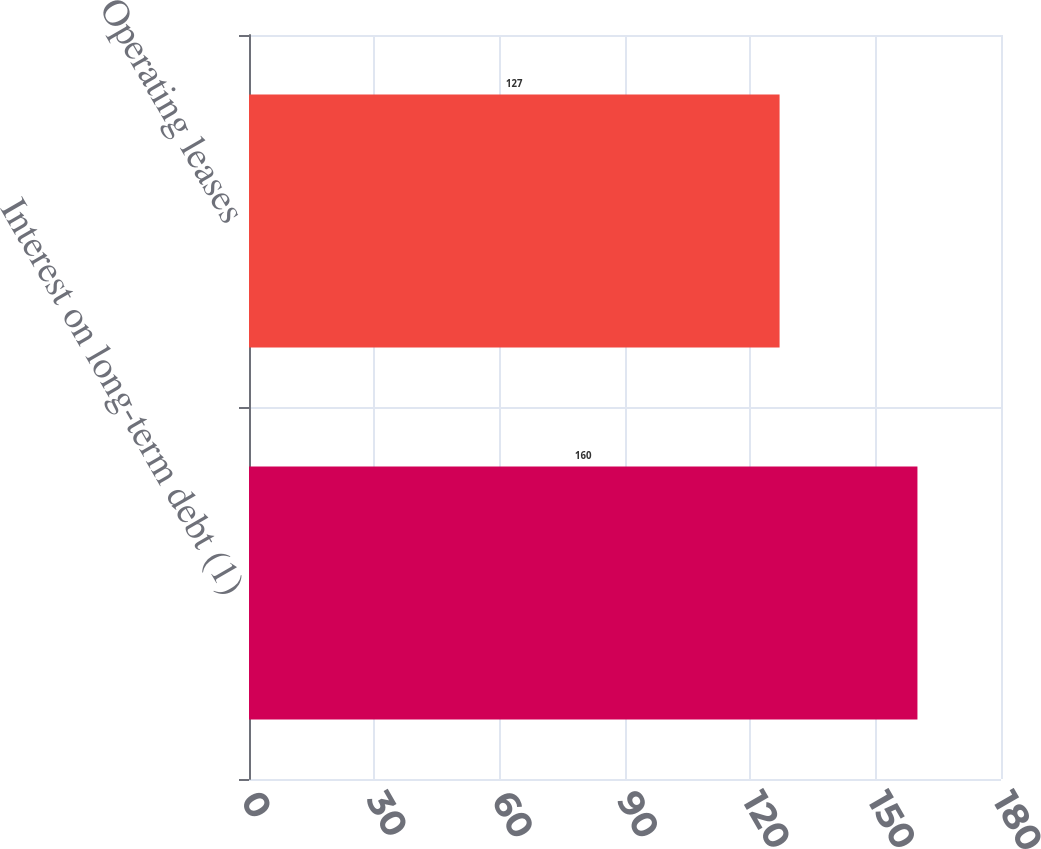Convert chart to OTSL. <chart><loc_0><loc_0><loc_500><loc_500><bar_chart><fcel>Interest on long-term debt (1)<fcel>Operating leases<nl><fcel>160<fcel>127<nl></chart> 